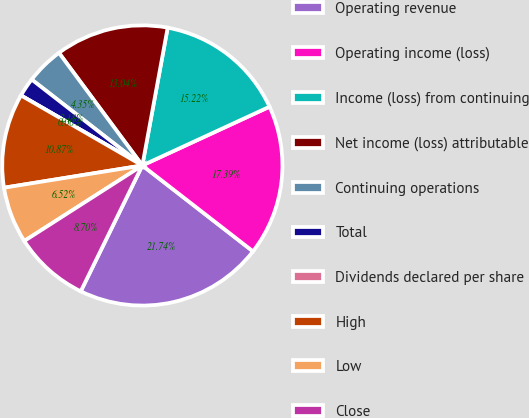Convert chart. <chart><loc_0><loc_0><loc_500><loc_500><pie_chart><fcel>Operating revenue<fcel>Operating income (loss)<fcel>Income (loss) from continuing<fcel>Net income (loss) attributable<fcel>Continuing operations<fcel>Total<fcel>Dividends declared per share<fcel>High<fcel>Low<fcel>Close<nl><fcel>21.74%<fcel>17.39%<fcel>15.22%<fcel>13.04%<fcel>4.35%<fcel>2.18%<fcel>0.0%<fcel>10.87%<fcel>6.52%<fcel>8.7%<nl></chart> 